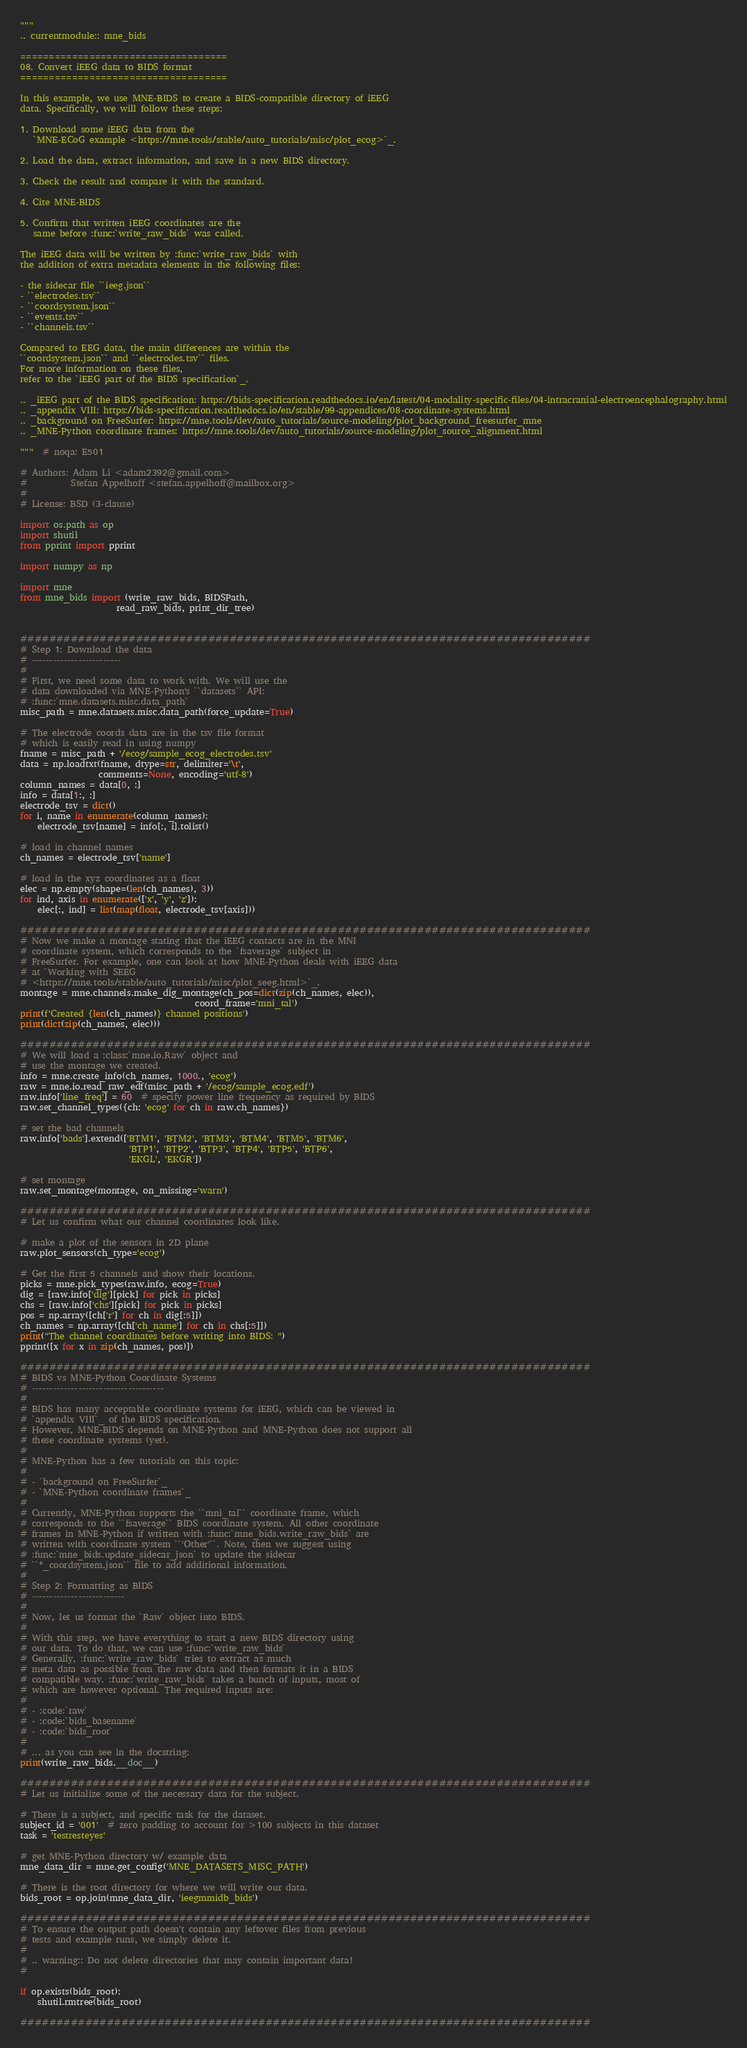<code> <loc_0><loc_0><loc_500><loc_500><_Python_>"""
.. currentmodule:: mne_bids

====================================
08. Convert iEEG data to BIDS format
====================================

In this example, we use MNE-BIDS to create a BIDS-compatible directory of iEEG
data. Specifically, we will follow these steps:

1. Download some iEEG data from the
   `MNE-ECoG example <https://mne.tools/stable/auto_tutorials/misc/plot_ecog>`_.

2. Load the data, extract information, and save in a new BIDS directory.

3. Check the result and compare it with the standard.

4. Cite MNE-BIDS

5. Confirm that written iEEG coordinates are the
   same before :func:`write_raw_bids` was called.

The iEEG data will be written by :func:`write_raw_bids` with
the addition of extra metadata elements in the following files:

- the sidecar file ``ieeg.json``
- ``electrodes.tsv``
- ``coordsystem.json``
- ``events.tsv``
- ``channels.tsv``

Compared to EEG data, the main differences are within the
``coordsystem.json`` and ``electrodes.tsv`` files.
For more information on these files,
refer to the `iEEG part of the BIDS specification`_.

.. _iEEG part of the BIDS specification: https://bids-specification.readthedocs.io/en/latest/04-modality-specific-files/04-intracranial-electroencephalography.html
.. _appendix VIII: https://bids-specification.readthedocs.io/en/stable/99-appendices/08-coordinate-systems.html
.. _background on FreeSurfer: https://mne.tools/dev/auto_tutorials/source-modeling/plot_background_freesurfer_mne
.. _MNE-Python coordinate frames: https://mne.tools/dev/auto_tutorials/source-modeling/plot_source_alignment.html

"""  # noqa: E501

# Authors: Adam Li <adam2392@gmail.com>
#          Stefan Appelhoff <stefan.appelhoff@mailbox.org>
#
# License: BSD (3-clause)

import os.path as op
import shutil
from pprint import pprint

import numpy as np

import mne
from mne_bids import (write_raw_bids, BIDSPath,
                      read_raw_bids, print_dir_tree)


###############################################################################
# Step 1: Download the data
# -------------------------
#
# First, we need some data to work with. We will use the
# data downloaded via MNE-Python's ``datasets`` API:
# :func:`mne.datasets.misc.data_path`
misc_path = mne.datasets.misc.data_path(force_update=True)

# The electrode coords data are in the tsv file format
# which is easily read in using numpy
fname = misc_path + '/ecog/sample_ecog_electrodes.tsv'
data = np.loadtxt(fname, dtype=str, delimiter='\t',
                  comments=None, encoding='utf-8')
column_names = data[0, :]
info = data[1:, :]
electrode_tsv = dict()
for i, name in enumerate(column_names):
    electrode_tsv[name] = info[:, i].tolist()

# load in channel names
ch_names = electrode_tsv['name']

# load in the xyz coordinates as a float
elec = np.empty(shape=(len(ch_names), 3))
for ind, axis in enumerate(['x', 'y', 'z']):
    elec[:, ind] = list(map(float, electrode_tsv[axis]))

###############################################################################
# Now we make a montage stating that the iEEG contacts are in the MNI
# coordinate system, which corresponds to the `fsaverage` subject in
# FreeSurfer. For example, one can look at how MNE-Python deals with iEEG data
# at `Working with SEEG
# <https://mne.tools/stable/auto_tutorials/misc/plot_seeg.html>`_.
montage = mne.channels.make_dig_montage(ch_pos=dict(zip(ch_names, elec)),
                                        coord_frame='mni_tal')
print(f'Created {len(ch_names)} channel positions')
print(dict(zip(ch_names, elec)))

###############################################################################
# We will load a :class:`mne.io.Raw` object and
# use the montage we created.
info = mne.create_info(ch_names, 1000., 'ecog')
raw = mne.io.read_raw_edf(misc_path + '/ecog/sample_ecog.edf')
raw.info['line_freq'] = 60  # specify power line frequency as required by BIDS
raw.set_channel_types({ch: 'ecog' for ch in raw.ch_names})

# set the bad channels
raw.info['bads'].extend(['BTM1', 'BTM2', 'BTM3', 'BTM4', 'BTM5', 'BTM6',
                         'BTP1', 'BTP2', 'BTP3', 'BTP4', 'BTP5', 'BTP6',
                         'EKGL', 'EKGR'])

# set montage
raw.set_montage(montage, on_missing='warn')

###############################################################################
# Let us confirm what our channel coordinates look like.

# make a plot of the sensors in 2D plane
raw.plot_sensors(ch_type='ecog')

# Get the first 5 channels and show their locations.
picks = mne.pick_types(raw.info, ecog=True)
dig = [raw.info['dig'][pick] for pick in picks]
chs = [raw.info['chs'][pick] for pick in picks]
pos = np.array([ch['r'] for ch in dig[:5]])
ch_names = np.array([ch['ch_name'] for ch in chs[:5]])
print("The channel coordinates before writing into BIDS: ")
pprint([x for x in zip(ch_names, pos)])

###############################################################################
# BIDS vs MNE-Python Coordinate Systems
# -------------------------------------
#
# BIDS has many acceptable coordinate systems for iEEG, which can be viewed in
# `appendix VIII`_ of the BIDS specification.
# However, MNE-BIDS depends on MNE-Python and MNE-Python does not support all
# these coordinate systems (yet).
#
# MNE-Python has a few tutorials on this topic:
#
# - `background on FreeSurfer`_
# - `MNE-Python coordinate frames`_
#
# Currently, MNE-Python supports the ``mni_tal`` coordinate frame, which
# corresponds to the ``fsaverage`` BIDS coordinate system. All other coordinate
# frames in MNE-Python if written with :func:`mne_bids.write_raw_bids` are
# written with coordinate system ``'Other'``. Note, then we suggest using
# :func:`mne_bids.update_sidecar_json` to update the sidecar
# ``*_coordsystem.json`` file to add additional information.
#
# Step 2: Formatting as BIDS
# --------------------------
#
# Now, let us format the `Raw` object into BIDS.
#
# With this step, we have everything to start a new BIDS directory using
# our data. To do that, we can use :func:`write_raw_bids`
# Generally, :func:`write_raw_bids` tries to extract as much
# meta data as possible from the raw data and then formats it in a BIDS
# compatible way. :func:`write_raw_bids` takes a bunch of inputs, most of
# which are however optional. The required inputs are:
#
# - :code:`raw`
# - :code:`bids_basename`
# - :code:`bids_root`
#
# ... as you can see in the docstring:
print(write_raw_bids.__doc__)

###############################################################################
# Let us initialize some of the necessary data for the subject.

# There is a subject, and specific task for the dataset.
subject_id = '001'  # zero padding to account for >100 subjects in this dataset
task = 'testresteyes'

# get MNE-Python directory w/ example data
mne_data_dir = mne.get_config('MNE_DATASETS_MISC_PATH')

# There is the root directory for where we will write our data.
bids_root = op.join(mne_data_dir, 'ieegmmidb_bids')

###############################################################################
# To ensure the output path doesn't contain any leftover files from previous
# tests and example runs, we simply delete it.
#
# .. warning:: Do not delete directories that may contain important data!
#

if op.exists(bids_root):
    shutil.rmtree(bids_root)

###############################################################################</code> 